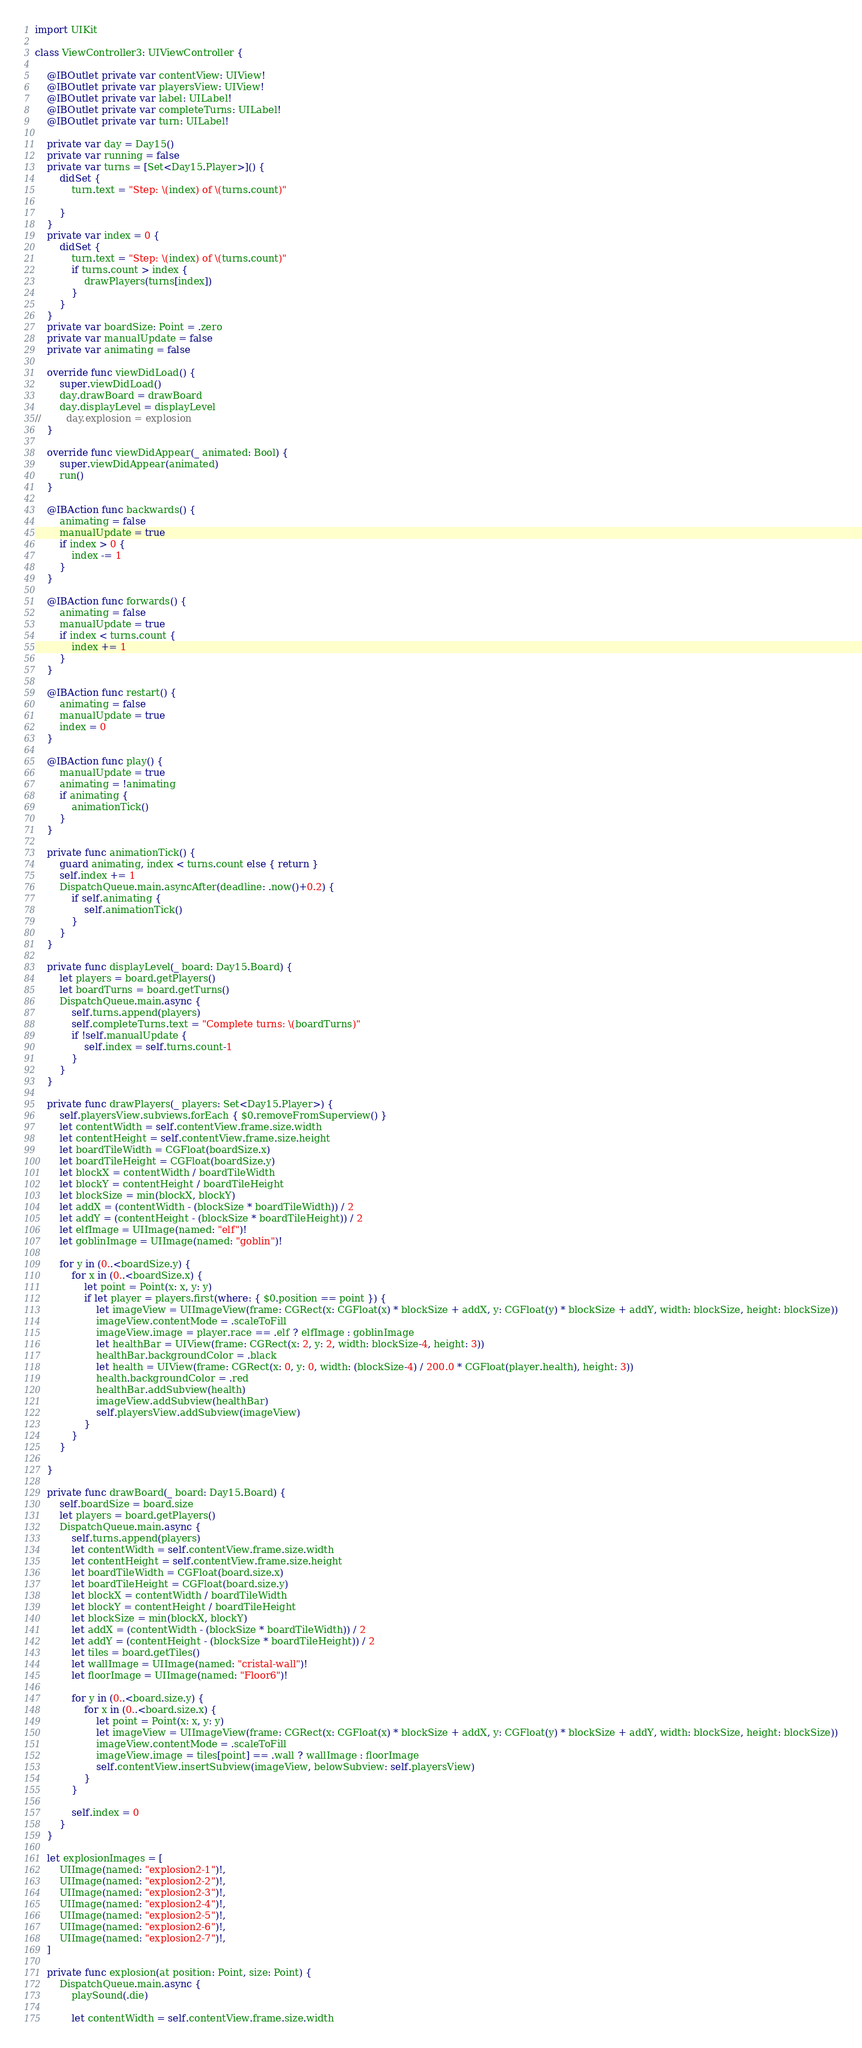<code> <loc_0><loc_0><loc_500><loc_500><_Swift_>import UIKit

class ViewController3: UIViewController {
    
    @IBOutlet private var contentView: UIView!
    @IBOutlet private var playersView: UIView!
    @IBOutlet private var label: UILabel!
    @IBOutlet private var completeTurns: UILabel!
    @IBOutlet private var turn: UILabel!
    
    private var day = Day15()
    private var running = false
    private var turns = [Set<Day15.Player>]() {
        didSet {
            turn.text = "Step: \(index) of \(turns.count)"
            
        }
    }
    private var index = 0 {
        didSet {
            turn.text = "Step: \(index) of \(turns.count)"
            if turns.count > index {
                drawPlayers(turns[index])
            }
        }
    }
    private var boardSize: Point = .zero
    private var manualUpdate = false
    private var animating = false
    
    override func viewDidLoad() {
        super.viewDidLoad()
        day.drawBoard = drawBoard
        day.displayLevel = displayLevel
//        day.explosion = explosion
    }

    override func viewDidAppear(_ animated: Bool) {
        super.viewDidAppear(animated)
        run()
    }
    
    @IBAction func backwards() {
        animating = false
        manualUpdate = true
        if index > 0 {
            index -= 1
        }
    }
    
    @IBAction func forwards() {
        animating = false
        manualUpdate = true
        if index < turns.count {
            index += 1
        }
    }
    
    @IBAction func restart() {
        animating = false
        manualUpdate = true
        index = 0
    }
    
    @IBAction func play() {
        manualUpdate = true
        animating = !animating
        if animating {
            animationTick()
        }
    }
    
    private func animationTick() {
        guard animating, index < turns.count else { return }
        self.index += 1
        DispatchQueue.main.asyncAfter(deadline: .now()+0.2) {
            if self.animating {
                self.animationTick()
            }
        }
    }

    private func displayLevel(_ board: Day15.Board) {
        let players = board.getPlayers()
        let boardTurns = board.getTurns()
        DispatchQueue.main.async {
            self.turns.append(players)
            self.completeTurns.text = "Complete turns: \(boardTurns)"
            if !self.manualUpdate {
                self.index = self.turns.count-1
            }
        }
    }
    
    private func drawPlayers(_ players: Set<Day15.Player>) {
        self.playersView.subviews.forEach { $0.removeFromSuperview() }
        let contentWidth = self.contentView.frame.size.width
        let contentHeight = self.contentView.frame.size.height
        let boardTileWidth = CGFloat(boardSize.x)
        let boardTileHeight = CGFloat(boardSize.y)
        let blockX = contentWidth / boardTileWidth
        let blockY = contentHeight / boardTileHeight
        let blockSize = min(blockX, blockY)
        let addX = (contentWidth - (blockSize * boardTileWidth)) / 2
        let addY = (contentHeight - (blockSize * boardTileHeight)) / 2
        let elfImage = UIImage(named: "elf")!
        let goblinImage = UIImage(named: "goblin")!

        for y in (0..<boardSize.y) {
            for x in (0..<boardSize.x) {
                let point = Point(x: x, y: y)
                if let player = players.first(where: { $0.position == point }) {
                    let imageView = UIImageView(frame: CGRect(x: CGFloat(x) * blockSize + addX, y: CGFloat(y) * blockSize + addY, width: blockSize, height: blockSize))
                    imageView.contentMode = .scaleToFill
                    imageView.image = player.race == .elf ? elfImage : goblinImage
                    let healthBar = UIView(frame: CGRect(x: 2, y: 2, width: blockSize-4, height: 3))
                    healthBar.backgroundColor = .black
                    let health = UIView(frame: CGRect(x: 0, y: 0, width: (blockSize-4) / 200.0 * CGFloat(player.health), height: 3))
                    health.backgroundColor = .red
                    healthBar.addSubview(health)
                    imageView.addSubview(healthBar)
                    self.playersView.addSubview(imageView)
                }
            }
        }

    }
    
    private func drawBoard(_ board: Day15.Board) {
        self.boardSize = board.size
        let players = board.getPlayers()
        DispatchQueue.main.async {
            self.turns.append(players)
            let contentWidth = self.contentView.frame.size.width
            let contentHeight = self.contentView.frame.size.height
            let boardTileWidth = CGFloat(board.size.x)
            let boardTileHeight = CGFloat(board.size.y)
            let blockX = contentWidth / boardTileWidth
            let blockY = contentHeight / boardTileHeight
            let blockSize = min(blockX, blockY)
            let addX = (contentWidth - (blockSize * boardTileWidth)) / 2
            let addY = (contentHeight - (blockSize * boardTileHeight)) / 2
            let tiles = board.getTiles()
            let wallImage = UIImage(named: "cristal-wall")!
            let floorImage = UIImage(named: "Floor6")!
            
            for y in (0..<board.size.y) {
                for x in (0..<board.size.x) {
                    let point = Point(x: x, y: y)
                    let imageView = UIImageView(frame: CGRect(x: CGFloat(x) * blockSize + addX, y: CGFloat(y) * blockSize + addY, width: blockSize, height: blockSize))
                    imageView.contentMode = .scaleToFill
                    imageView.image = tiles[point] == .wall ? wallImage : floorImage
                    self.contentView.insertSubview(imageView, belowSubview: self.playersView)
                }
            }
            
            self.index = 0
        }
    }
    
    let explosionImages = [
        UIImage(named: "explosion2-1")!,
        UIImage(named: "explosion2-2")!,
        UIImage(named: "explosion2-3")!,
        UIImage(named: "explosion2-4")!,
        UIImage(named: "explosion2-5")!,
        UIImage(named: "explosion2-6")!,
        UIImage(named: "explosion2-7")!,
    ]
    
    private func explosion(at position: Point, size: Point) {
        DispatchQueue.main.async {
            playSound(.die)
            
            let contentWidth = self.contentView.frame.size.width</code> 